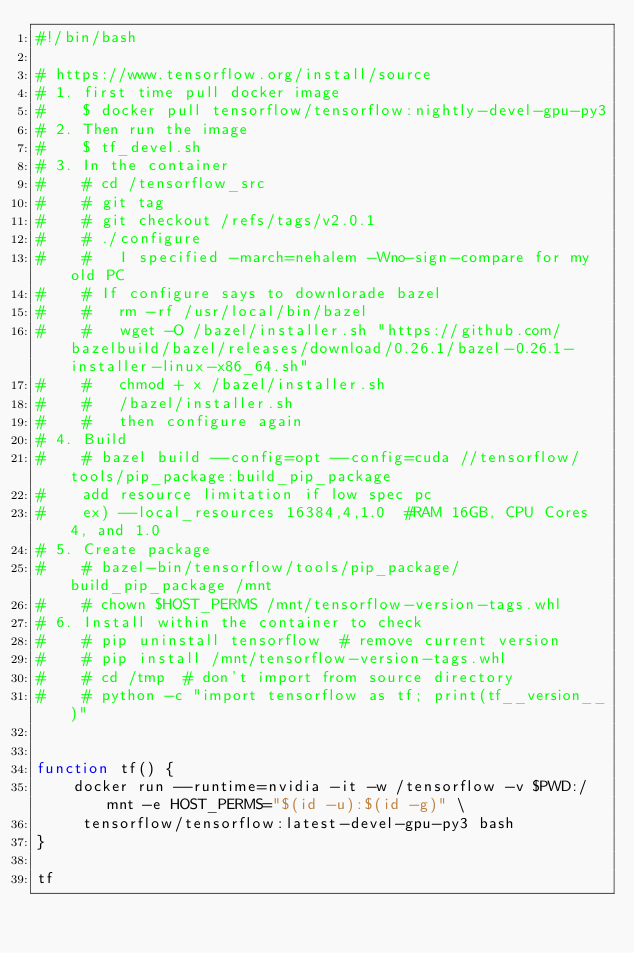Convert code to text. <code><loc_0><loc_0><loc_500><loc_500><_Bash_>#!/bin/bash

# https://www.tensorflow.org/install/source
# 1. first time pull docker image
#    $ docker pull tensorflow/tensorflow:nightly-devel-gpu-py3
# 2. Then run the image
#    $ tf_devel.sh
# 3. In the container
#    # cd /tensorflow_src
#    # git tag
#    # git checkout /refs/tags/v2.0.1
#    # ./configure
#    #   I specified -march=nehalem -Wno-sign-compare for my old PC
#    # If configure says to downlorade bazel
#    #   rm -rf /usr/local/bin/bazel
#    #   wget -O /bazel/installer.sh "https://github.com/bazelbuild/bazel/releases/download/0.26.1/bazel-0.26.1-installer-linux-x86_64.sh"
#    #   chmod + x /bazel/installer.sh
#    #   /bazel/installer.sh
#    #   then configure again
# 4. Build
#    # bazel build --config=opt --config=cuda //tensorflow/tools/pip_package:build_pip_package
#    add resource limitation if low spec pc
#    ex) --local_resources 16384,4,1.0  #RAM 16GB, CPU Cores 4, and 1.0
# 5. Create package
#    # bazel-bin/tensorflow/tools/pip_package/build_pip_package /mnt
#    # chown $HOST_PERMS /mnt/tensorflow-version-tags.whl
# 6. Install within the container to check
#    # pip uninstall tensorflow  # remove current version
#    # pip install /mnt/tensorflow-version-tags.whl
#    # cd /tmp  # don't import from source directory
#    # python -c "import tensorflow as tf; print(tf__version__)"


function tf() {
    docker run --runtime=nvidia -it -w /tensorflow -v $PWD:/mnt -e HOST_PERMS="$(id -u):$(id -g)" \
	   tensorflow/tensorflow:latest-devel-gpu-py3 bash
}

tf
</code> 